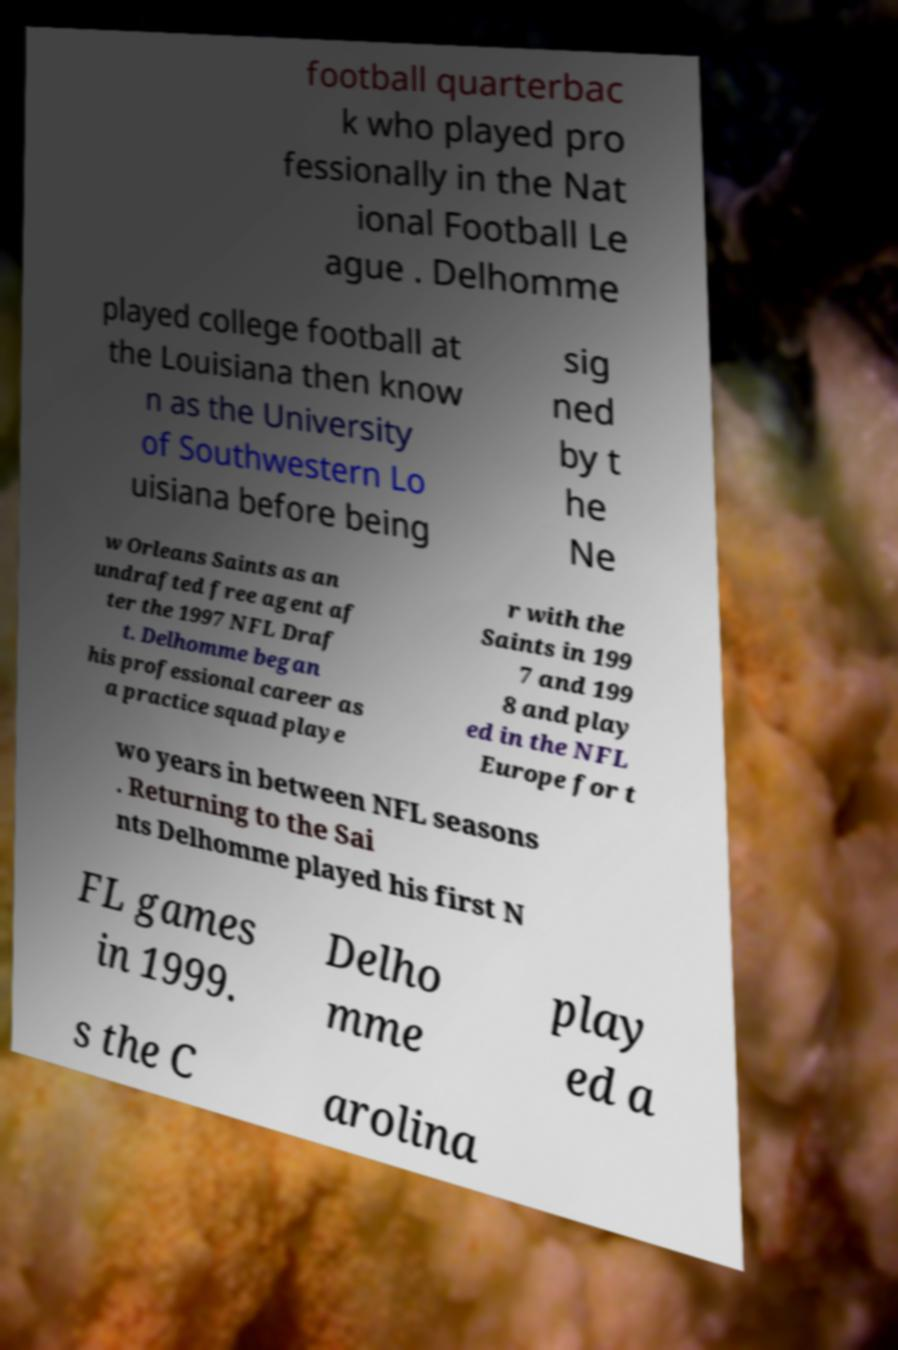Can you read and provide the text displayed in the image?This photo seems to have some interesting text. Can you extract and type it out for me? football quarterbac k who played pro fessionally in the Nat ional Football Le ague . Delhomme played college football at the Louisiana then know n as the University of Southwestern Lo uisiana before being sig ned by t he Ne w Orleans Saints as an undrafted free agent af ter the 1997 NFL Draf t. Delhomme began his professional career as a practice squad playe r with the Saints in 199 7 and 199 8 and play ed in the NFL Europe for t wo years in between NFL seasons . Returning to the Sai nts Delhomme played his first N FL games in 1999. Delho mme play ed a s the C arolina 